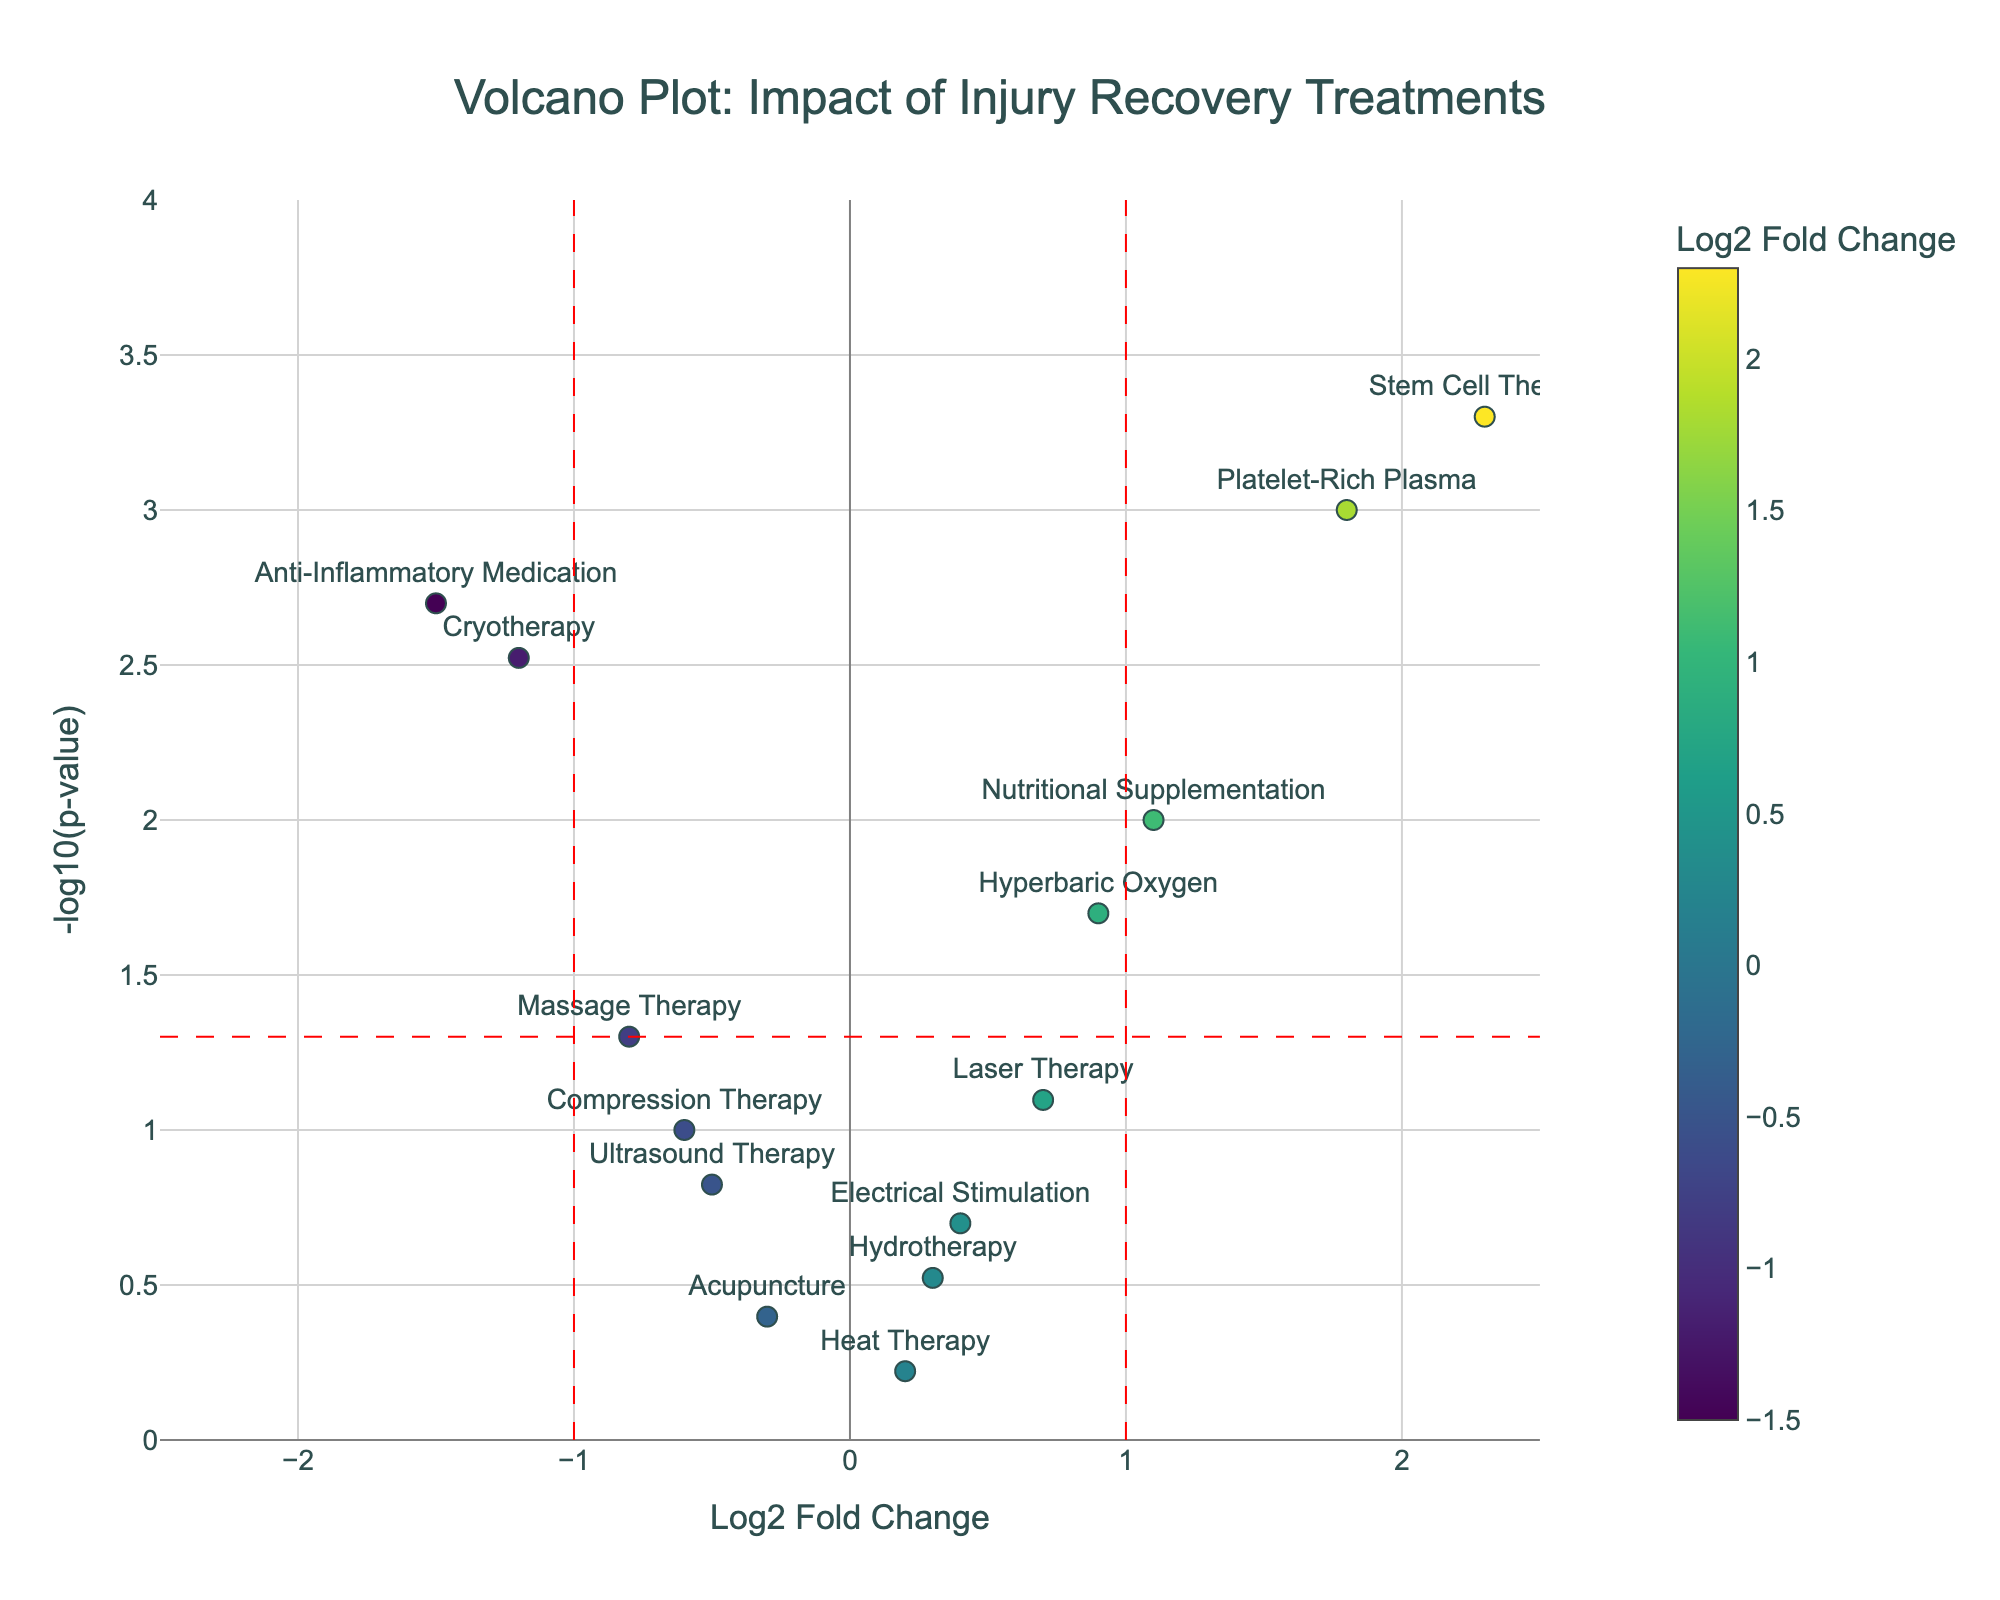What is the title of the Volcano Plot? The title is located at the top of the figure. It reads "Volcano Plot: Impact of Injury Recovery Treatments."
Answer: Volcano Plot: Impact of Injury Recovery Treatments Which treatment has the highest log2 fold change? By looking at the x-axis, the treatment with the highest positive log2 fold change is farthest to the right. According to the plot, it is Stem Cell Therapy with a value of approximately 2.3.
Answer: Stem Cell Therapy Which treatments have significant changes in inflammation markers according to the plot? Significant changes are indicated by points above the horizontal red dashed line (-log10(p-value) > 1.3) and beyond the vertical red dashed lines (log2 fold change < -1 or > 1). The treatments Cryotherapy, Platelet-Rich Plasma, Stem Cell Therapy, Nutritional Supplementation, and Anti-Inflammatory Medication meet these criteria.
Answer: Cryotherapy, Platelet-Rich Plasma, Stem Cell Therapy, Nutritional Supplementation, Anti-Inflammatory Medication How does Cryotherapy compare to Anti-Inflammatory Medication in terms of log2 fold change? Cryotherapy has a log2 fold change of -1.2 whereas Anti-Inflammatory Medication has a log2 fold change of -1.5. Thus, Anti-Inflammatory Medication reduces inflammation markers more significantly than Cryotherapy.
Answer: Anti-Inflammatory Medication reduces inflammation more What is the p-value for Platelet-Rich Plasma, and is it significant? By examining the hover information or looking at the y-axis, Platelet-Rich Plasma has a p-value of 0.001, and its -log10(p-value) is above 1.3, confirming it's significant.
Answer: 0.001, significant Which treatments are not considered statistically significant in changing inflammation markers? Non-significant points lie below the horizontal red dashed line (-log10(p-value) ≤ 1.3). These treatments include Ultrasound Therapy, Laser Therapy, Acupuncture, Electrical Stimulation, Heat Therapy, Compression Therapy, and Hydrotherapy.
Answer: Ultrasound Therapy, Laser Therapy, Acupuncture, Electrical Stimulation, Heat Therapy, Compression Therapy, Hydrotherapy Between Massage Therapy and Nutritional Supplementation, which one shows a greater reduction in inflammation markers and is it significant? Massage Therapy has a log2 fold change of -0.8, and Nutritional Supplementation has 1.1. Nutritional Supplementation indicates an increase rather than a reduction in inflammation markers. Regarding significance, Nutritional Supplementation is significant (p < 0.05), while Massage Therapy is at the threshold of significance (just below the horizontal red line).
Answer: Massage Therapy has a greater reduction, only Nutritional Supplementation is significant What is the log2 fold change and p-value for Hyperbaric Oxygen treatment? By looking at the Volcano Plot, Hyperbaric Oxygen treatment has a log2 fold change of approximately 0.9 and a p-value of about 0.02, inferred from the hover information.
Answer: 0.9, 0.02 Which treatment closest to the origin shows minor changes in inflammation markers? The origin of the plot (0,0) represents no change. Heat Therapy is closest to the origin with log2 fold change almost 0 and a p-value indicating non-significance, represented by its proximity to the horizontal axis baseline.
Answer: Heat Therapy 